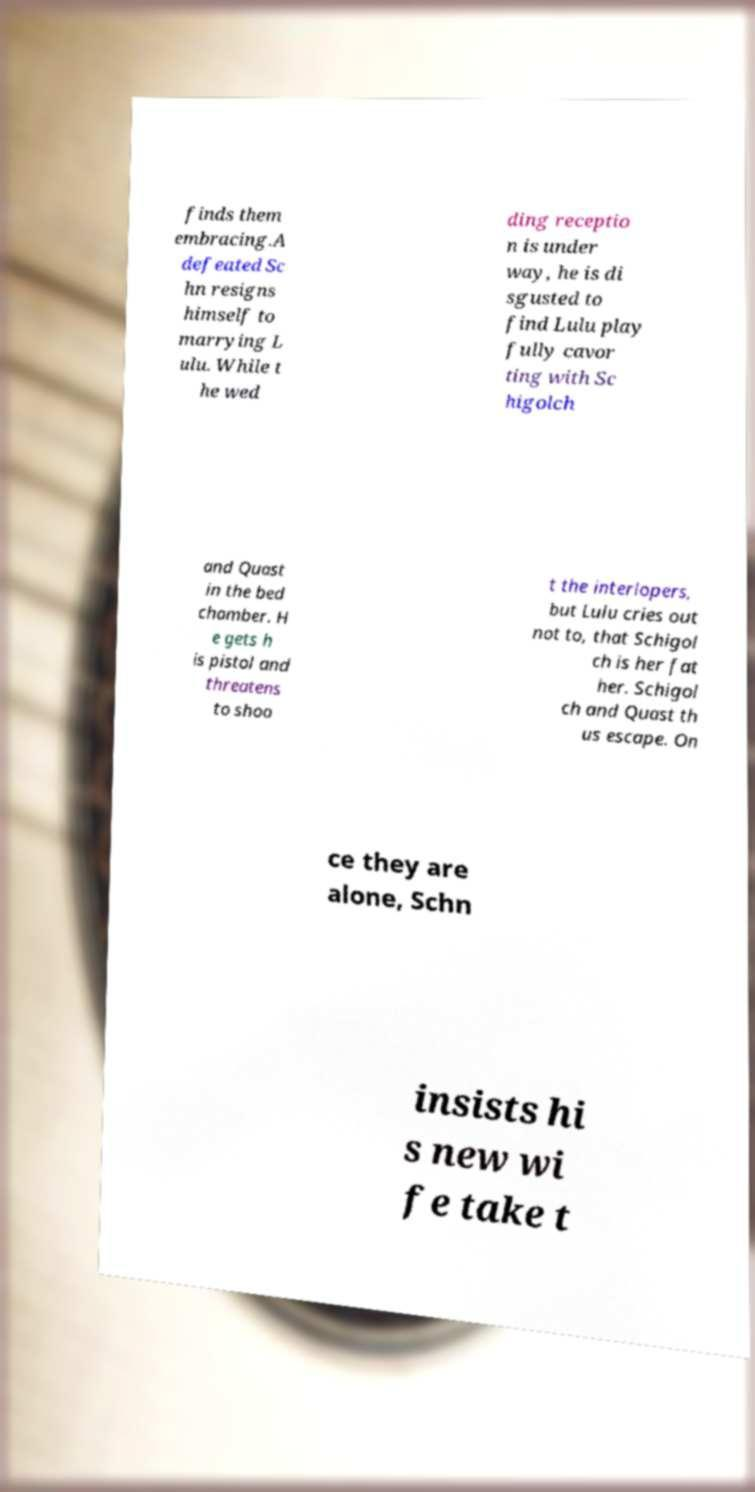There's text embedded in this image that I need extracted. Can you transcribe it verbatim? finds them embracing.A defeated Sc hn resigns himself to marrying L ulu. While t he wed ding receptio n is under way, he is di sgusted to find Lulu play fully cavor ting with Sc higolch and Quast in the bed chamber. H e gets h is pistol and threatens to shoo t the interlopers, but Lulu cries out not to, that Schigol ch is her fat her. Schigol ch and Quast th us escape. On ce they are alone, Schn insists hi s new wi fe take t 